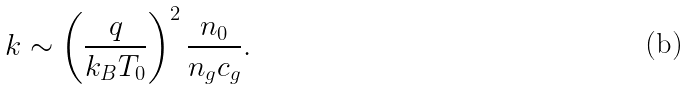<formula> <loc_0><loc_0><loc_500><loc_500>k \sim \left ( \frac { q } { k _ { B } T _ { 0 } } \right ) ^ { 2 } \frac { n _ { 0 } } { n _ { g } c _ { g } } .</formula> 